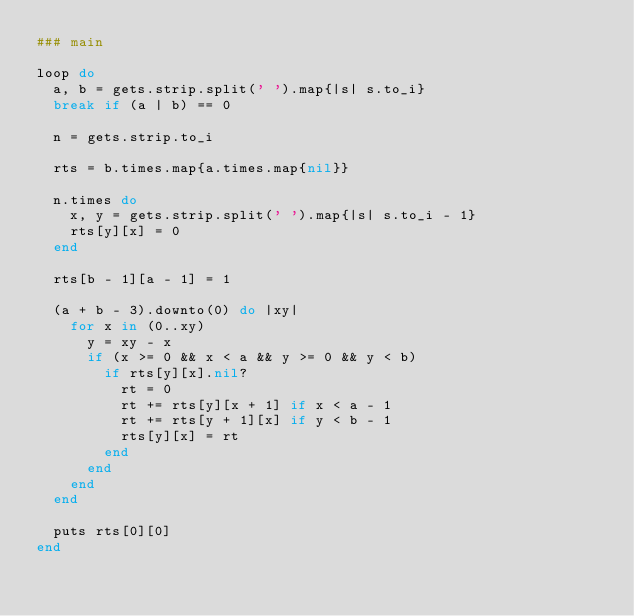Convert code to text. <code><loc_0><loc_0><loc_500><loc_500><_Ruby_>### main

loop do
  a, b = gets.strip.split(' ').map{|s| s.to_i}
  break if (a | b) == 0

  n = gets.strip.to_i

  rts = b.times.map{a.times.map{nil}}

  n.times do
    x, y = gets.strip.split(' ').map{|s| s.to_i - 1}
    rts[y][x] = 0
  end

  rts[b - 1][a - 1] = 1

  (a + b - 3).downto(0) do |xy|
    for x in (0..xy)
      y = xy - x
      if (x >= 0 && x < a && y >= 0 && y < b)
        if rts[y][x].nil?
          rt = 0
          rt += rts[y][x + 1] if x < a - 1
          rt += rts[y + 1][x] if y < b - 1
          rts[y][x] = rt
        end
      end
    end
  end

  puts rts[0][0]
end</code> 